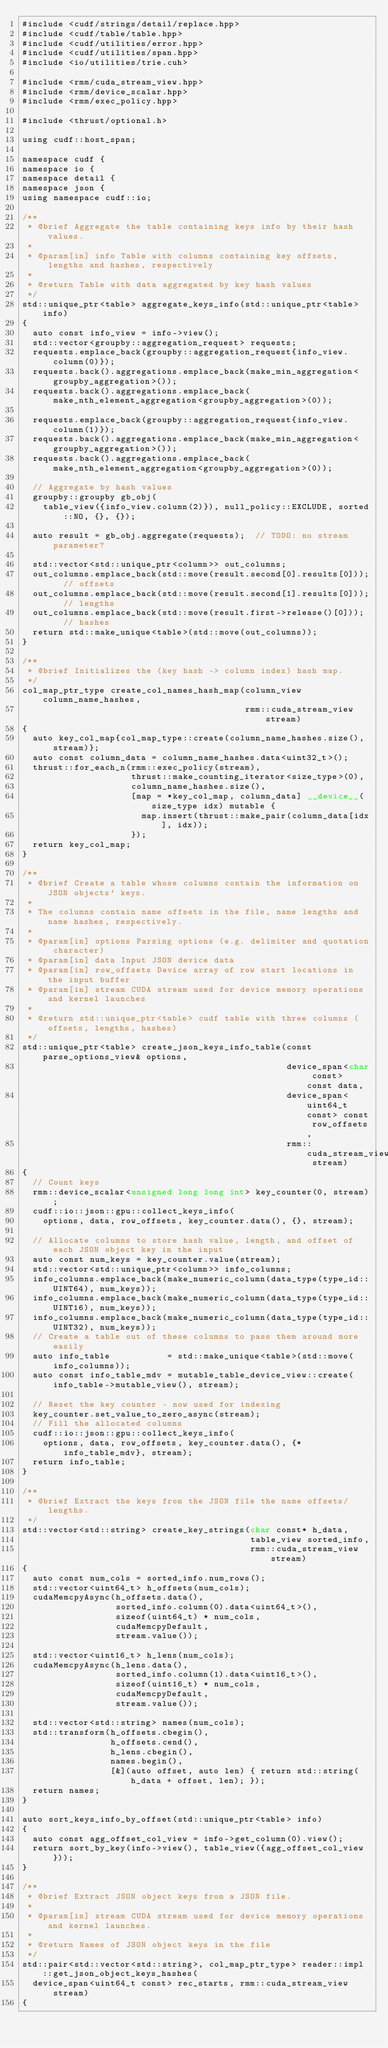Convert code to text. <code><loc_0><loc_0><loc_500><loc_500><_Cuda_>#include <cudf/strings/detail/replace.hpp>
#include <cudf/table/table.hpp>
#include <cudf/utilities/error.hpp>
#include <cudf/utilities/span.hpp>
#include <io/utilities/trie.cuh>

#include <rmm/cuda_stream_view.hpp>
#include <rmm/device_scalar.hpp>
#include <rmm/exec_policy.hpp>

#include <thrust/optional.h>

using cudf::host_span;

namespace cudf {
namespace io {
namespace detail {
namespace json {
using namespace cudf::io;

/**
 * @brief Aggregate the table containing keys info by their hash values.
 *
 * @param[in] info Table with columns containing key offsets, lengths and hashes, respectively
 *
 * @return Table with data aggregated by key hash values
 */
std::unique_ptr<table> aggregate_keys_info(std::unique_ptr<table> info)
{
  auto const info_view = info->view();
  std::vector<groupby::aggregation_request> requests;
  requests.emplace_back(groupby::aggregation_request{info_view.column(0)});
  requests.back().aggregations.emplace_back(make_min_aggregation<groupby_aggregation>());
  requests.back().aggregations.emplace_back(make_nth_element_aggregation<groupby_aggregation>(0));

  requests.emplace_back(groupby::aggregation_request{info_view.column(1)});
  requests.back().aggregations.emplace_back(make_min_aggregation<groupby_aggregation>());
  requests.back().aggregations.emplace_back(make_nth_element_aggregation<groupby_aggregation>(0));

  // Aggregate by hash values
  groupby::groupby gb_obj(
    table_view({info_view.column(2)}), null_policy::EXCLUDE, sorted::NO, {}, {});

  auto result = gb_obj.aggregate(requests);  // TODO: no stream parameter?

  std::vector<std::unique_ptr<column>> out_columns;
  out_columns.emplace_back(std::move(result.second[0].results[0]));  // offsets
  out_columns.emplace_back(std::move(result.second[1].results[0]));  // lengths
  out_columns.emplace_back(std::move(result.first->release()[0]));   // hashes
  return std::make_unique<table>(std::move(out_columns));
}

/**
 * @brief Initializes the (key hash -> column index) hash map.
 */
col_map_ptr_type create_col_names_hash_map(column_view column_name_hashes,
                                           rmm::cuda_stream_view stream)
{
  auto key_col_map{col_map_type::create(column_name_hashes.size(), stream)};
  auto const column_data = column_name_hashes.data<uint32_t>();
  thrust::for_each_n(rmm::exec_policy(stream),
                     thrust::make_counting_iterator<size_type>(0),
                     column_name_hashes.size(),
                     [map = *key_col_map, column_data] __device__(size_type idx) mutable {
                       map.insert(thrust::make_pair(column_data[idx], idx));
                     });
  return key_col_map;
}

/**
 * @brief Create a table whose columns contain the information on JSON objects' keys.
 *
 * The columns contain name offsets in the file, name lengths and name hashes, respectively.
 *
 * @param[in] options Parsing options (e.g. delimiter and quotation character)
 * @param[in] data Input JSON device data
 * @param[in] row_offsets Device array of row start locations in the input buffer
 * @param[in] stream CUDA stream used for device memory operations and kernel launches
 *
 * @return std::unique_ptr<table> cudf table with three columns (offsets, lengths, hashes)
 */
std::unique_ptr<table> create_json_keys_info_table(const parse_options_view& options,
                                                   device_span<char const> const data,
                                                   device_span<uint64_t const> const row_offsets,
                                                   rmm::cuda_stream_view stream)
{
  // Count keys
  rmm::device_scalar<unsigned long long int> key_counter(0, stream);
  cudf::io::json::gpu::collect_keys_info(
    options, data, row_offsets, key_counter.data(), {}, stream);

  // Allocate columns to store hash value, length, and offset of each JSON object key in the input
  auto const num_keys = key_counter.value(stream);
  std::vector<std::unique_ptr<column>> info_columns;
  info_columns.emplace_back(make_numeric_column(data_type(type_id::UINT64), num_keys));
  info_columns.emplace_back(make_numeric_column(data_type(type_id::UINT16), num_keys));
  info_columns.emplace_back(make_numeric_column(data_type(type_id::UINT32), num_keys));
  // Create a table out of these columns to pass them around more easily
  auto info_table           = std::make_unique<table>(std::move(info_columns));
  auto const info_table_mdv = mutable_table_device_view::create(info_table->mutable_view(), stream);

  // Reset the key counter - now used for indexing
  key_counter.set_value_to_zero_async(stream);
  // Fill the allocated columns
  cudf::io::json::gpu::collect_keys_info(
    options, data, row_offsets, key_counter.data(), {*info_table_mdv}, stream);
  return info_table;
}

/**
 * @brief Extract the keys from the JSON file the name offsets/lengths.
 */
std::vector<std::string> create_key_strings(char const* h_data,
                                            table_view sorted_info,
                                            rmm::cuda_stream_view stream)
{
  auto const num_cols = sorted_info.num_rows();
  std::vector<uint64_t> h_offsets(num_cols);
  cudaMemcpyAsync(h_offsets.data(),
                  sorted_info.column(0).data<uint64_t>(),
                  sizeof(uint64_t) * num_cols,
                  cudaMemcpyDefault,
                  stream.value());

  std::vector<uint16_t> h_lens(num_cols);
  cudaMemcpyAsync(h_lens.data(),
                  sorted_info.column(1).data<uint16_t>(),
                  sizeof(uint16_t) * num_cols,
                  cudaMemcpyDefault,
                  stream.value());

  std::vector<std::string> names(num_cols);
  std::transform(h_offsets.cbegin(),
                 h_offsets.cend(),
                 h_lens.cbegin(),
                 names.begin(),
                 [&](auto offset, auto len) { return std::string(h_data + offset, len); });
  return names;
}

auto sort_keys_info_by_offset(std::unique_ptr<table> info)
{
  auto const agg_offset_col_view = info->get_column(0).view();
  return sort_by_key(info->view(), table_view({agg_offset_col_view}));
}

/**
 * @brief Extract JSON object keys from a JSON file.
 *
 * @param[in] stream CUDA stream used for device memory operations and kernel launches.
 *
 * @return Names of JSON object keys in the file
 */
std::pair<std::vector<std::string>, col_map_ptr_type> reader::impl::get_json_object_keys_hashes(
  device_span<uint64_t const> rec_starts, rmm::cuda_stream_view stream)
{</code> 